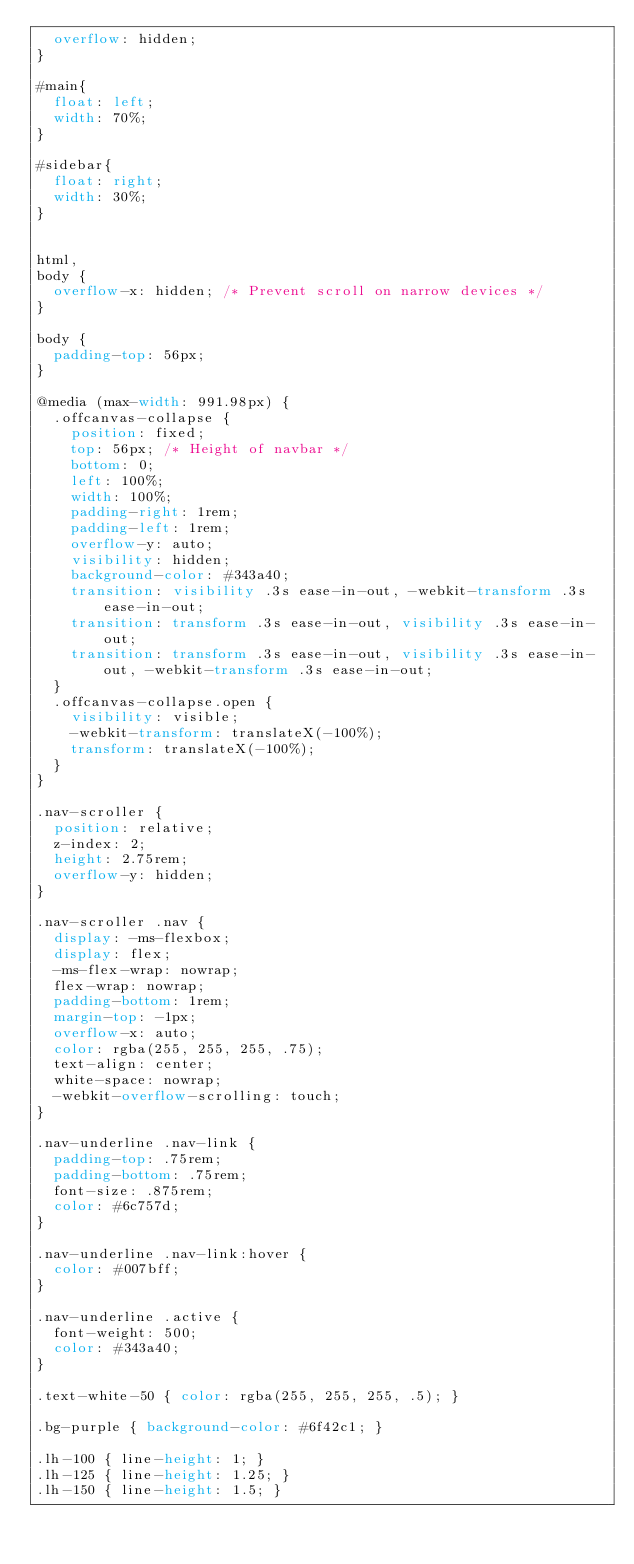<code> <loc_0><loc_0><loc_500><loc_500><_CSS_>  overflow: hidden;
}

#main{
  float: left;
  width: 70%;
}

#sidebar{
  float: right;
  width: 30%;
}


html,
body {
  overflow-x: hidden; /* Prevent scroll on narrow devices */
}

body {
  padding-top: 56px;
}

@media (max-width: 991.98px) {
  .offcanvas-collapse {
    position: fixed;
    top: 56px; /* Height of navbar */
    bottom: 0;
    left: 100%;
    width: 100%;
    padding-right: 1rem;
    padding-left: 1rem;
    overflow-y: auto;
    visibility: hidden;
    background-color: #343a40;
    transition: visibility .3s ease-in-out, -webkit-transform .3s ease-in-out;
    transition: transform .3s ease-in-out, visibility .3s ease-in-out;
    transition: transform .3s ease-in-out, visibility .3s ease-in-out, -webkit-transform .3s ease-in-out;
  }
  .offcanvas-collapse.open {
    visibility: visible;
    -webkit-transform: translateX(-100%);
    transform: translateX(-100%);
  }
}

.nav-scroller {
  position: relative;
  z-index: 2;
  height: 2.75rem;
  overflow-y: hidden;
}

.nav-scroller .nav {
  display: -ms-flexbox;
  display: flex;
  -ms-flex-wrap: nowrap;
  flex-wrap: nowrap;
  padding-bottom: 1rem;
  margin-top: -1px;
  overflow-x: auto;
  color: rgba(255, 255, 255, .75);
  text-align: center;
  white-space: nowrap;
  -webkit-overflow-scrolling: touch;
}

.nav-underline .nav-link {
  padding-top: .75rem;
  padding-bottom: .75rem;
  font-size: .875rem;
  color: #6c757d;
}

.nav-underline .nav-link:hover {
  color: #007bff;
}

.nav-underline .active {
  font-weight: 500;
  color: #343a40;
}

.text-white-50 { color: rgba(255, 255, 255, .5); }

.bg-purple { background-color: #6f42c1; }

.lh-100 { line-height: 1; }
.lh-125 { line-height: 1.25; }
.lh-150 { line-height: 1.5; }
</code> 